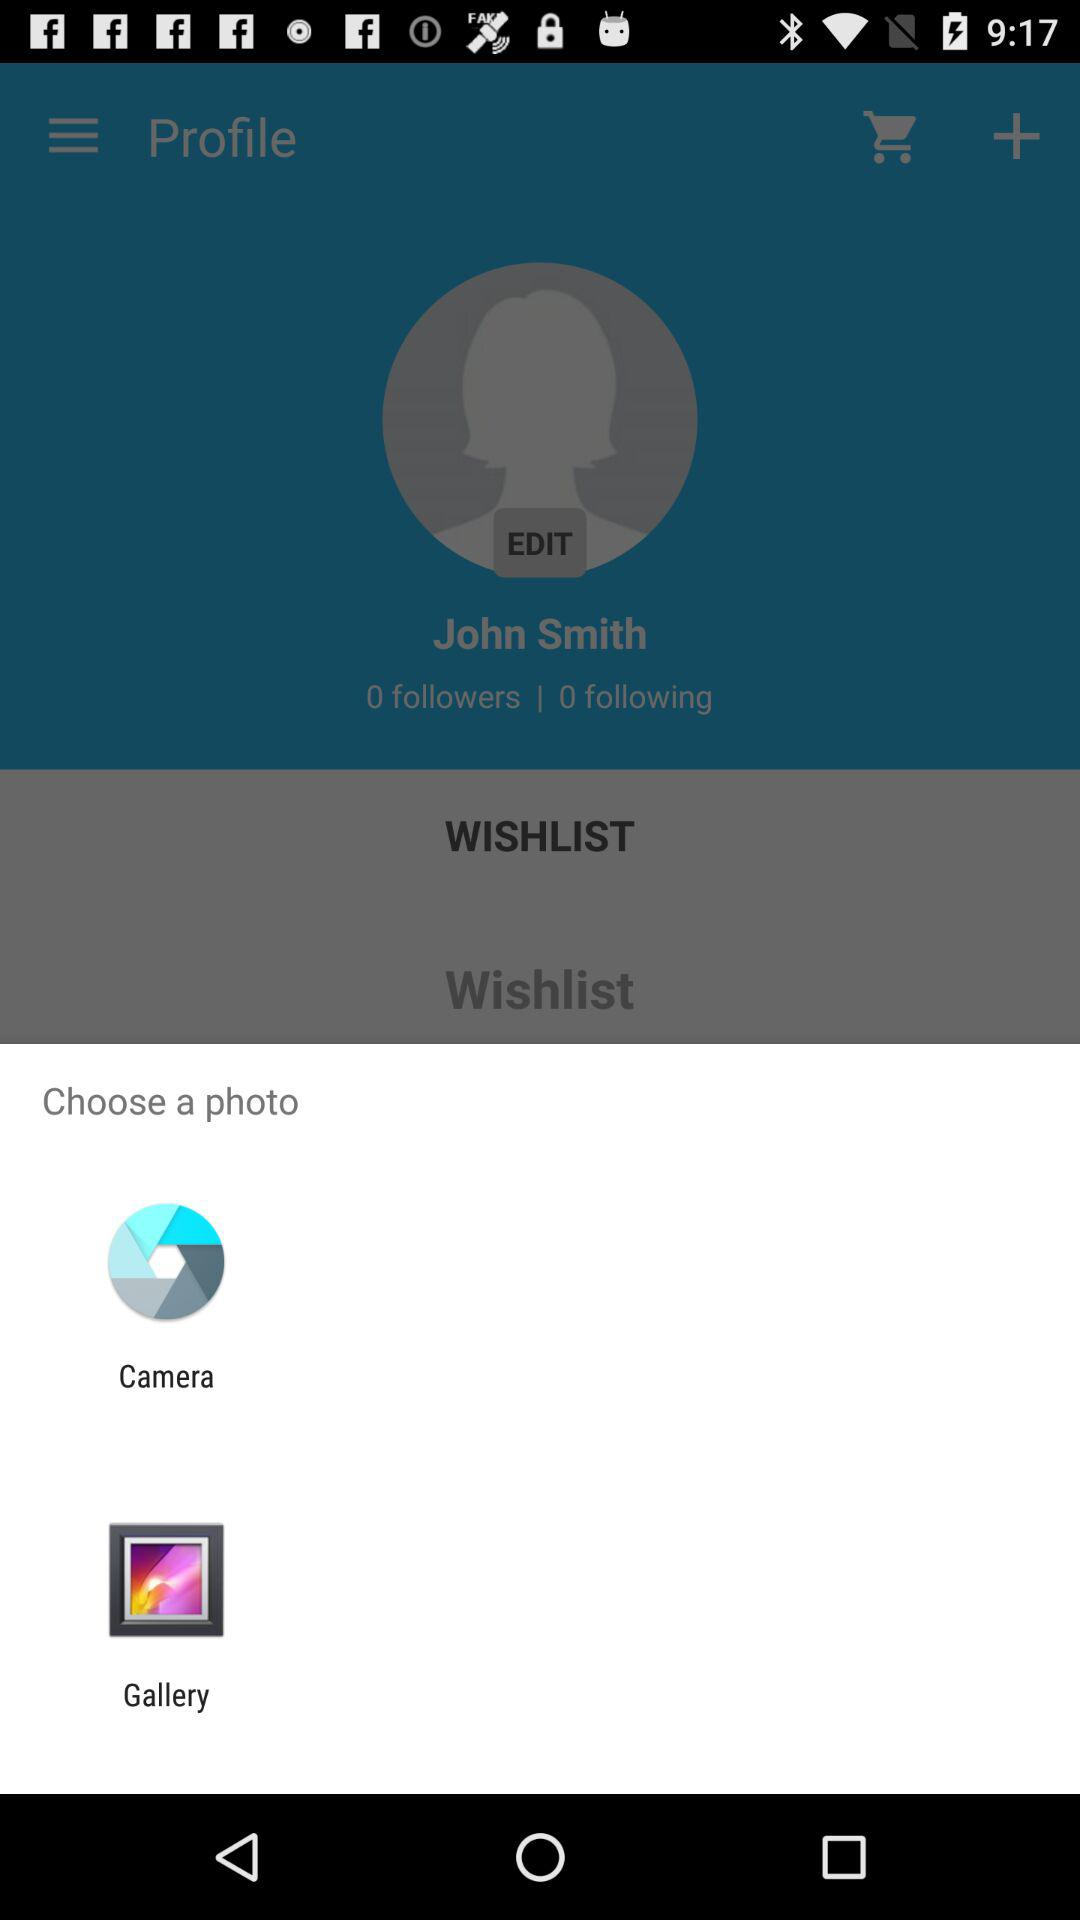What are the different options available for choosing a photo? The different available options are "Camera" and "Gallery". 